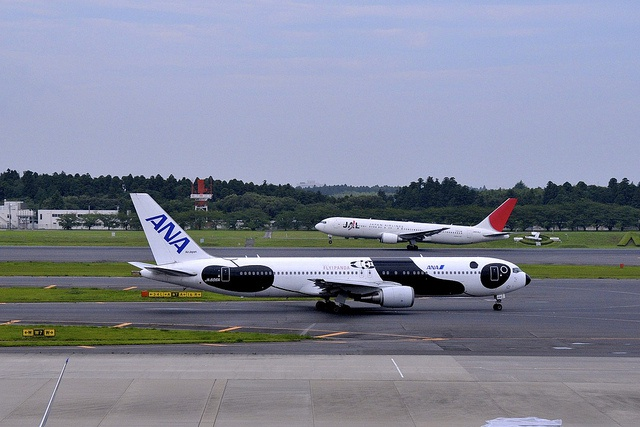Describe the objects in this image and their specific colors. I can see airplane in lavender, black, darkgray, and gray tones and airplane in lavender, black, and darkgray tones in this image. 